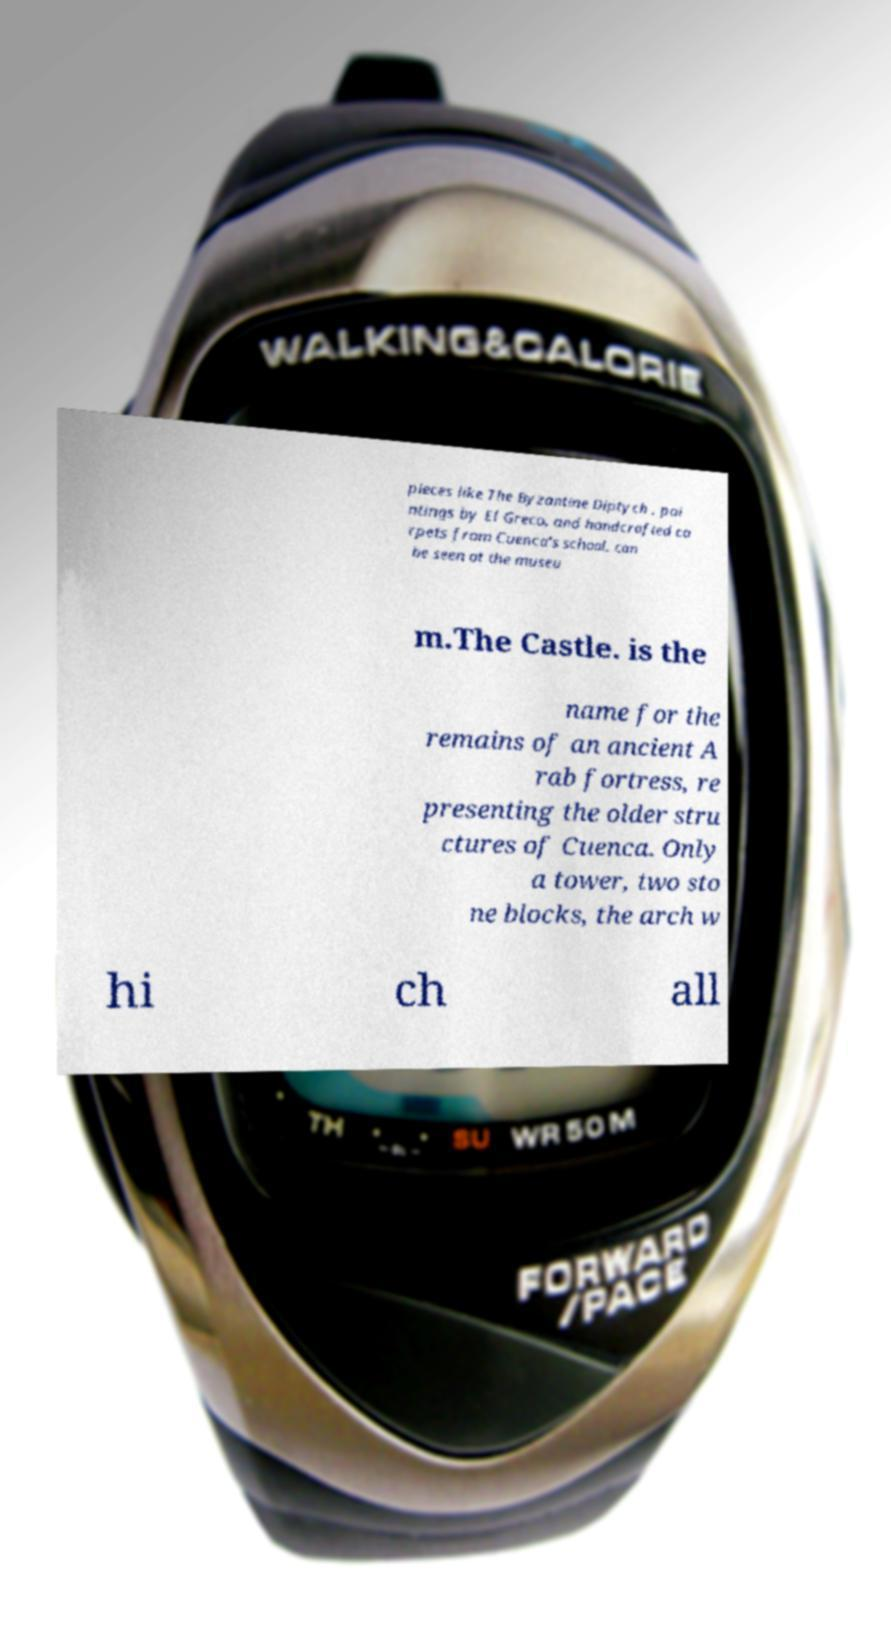Could you assist in decoding the text presented in this image and type it out clearly? pieces like The Byzantine Diptych , pai ntings by El Greco, and handcrafted ca rpets from Cuenca's school, can be seen at the museu m.The Castle. is the name for the remains of an ancient A rab fortress, re presenting the older stru ctures of Cuenca. Only a tower, two sto ne blocks, the arch w hi ch all 